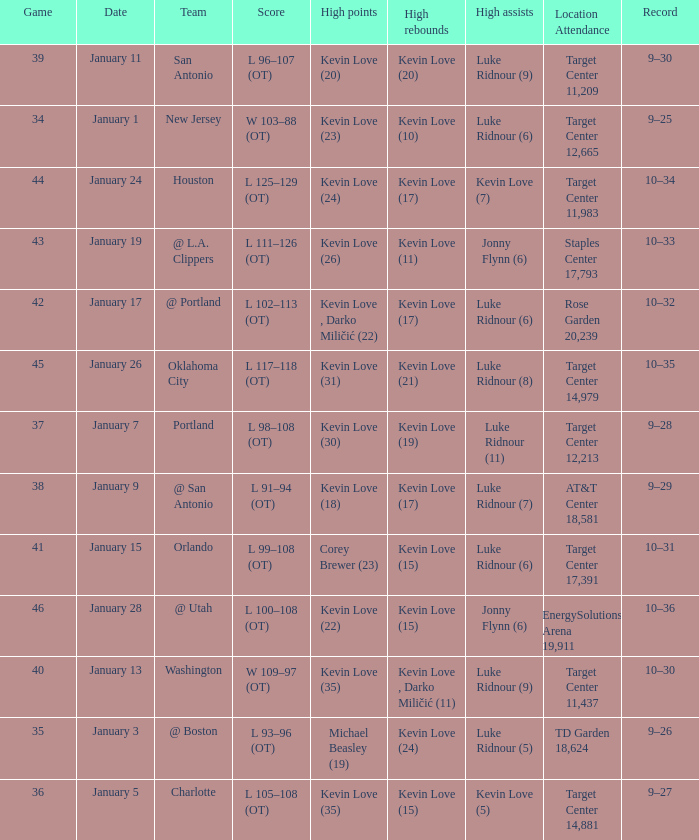Who had the high points when the team was charlotte? Kevin Love (35). 